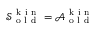<formula> <loc_0><loc_0><loc_500><loc_500>\mathcal { S } _ { o l d } ^ { k i n } = \mathcal { A } _ { o l d } ^ { k i n }</formula> 